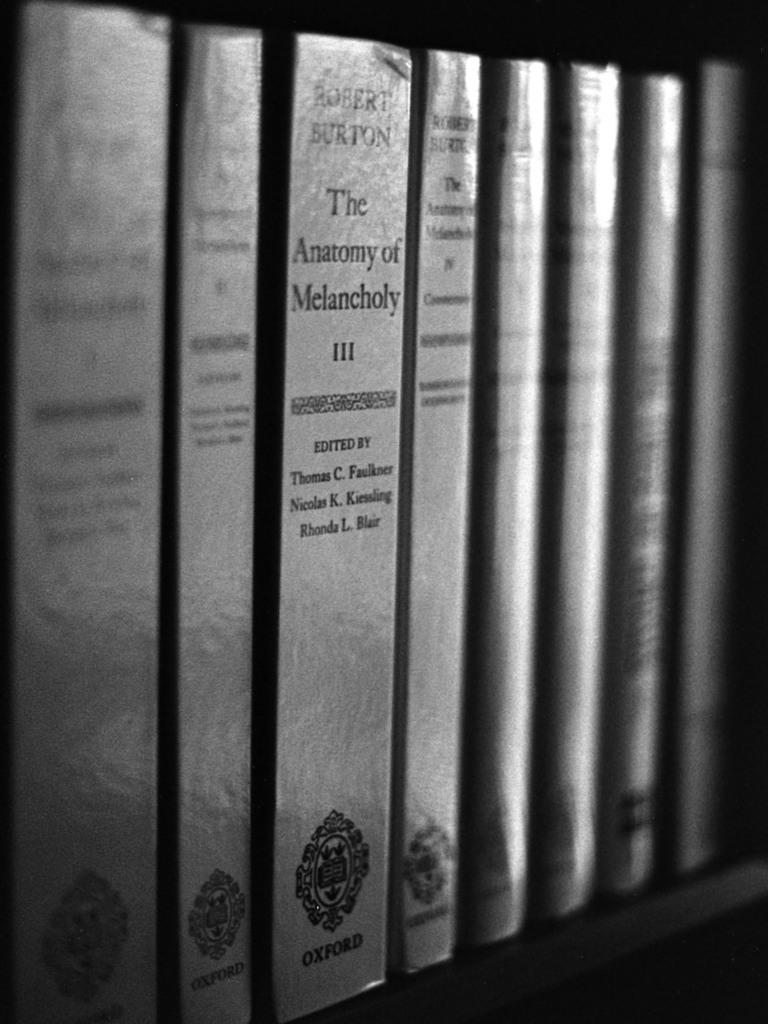<image>
Share a concise interpretation of the image provided. The Anatomy of Melancholy sits on a shelf with other books. 